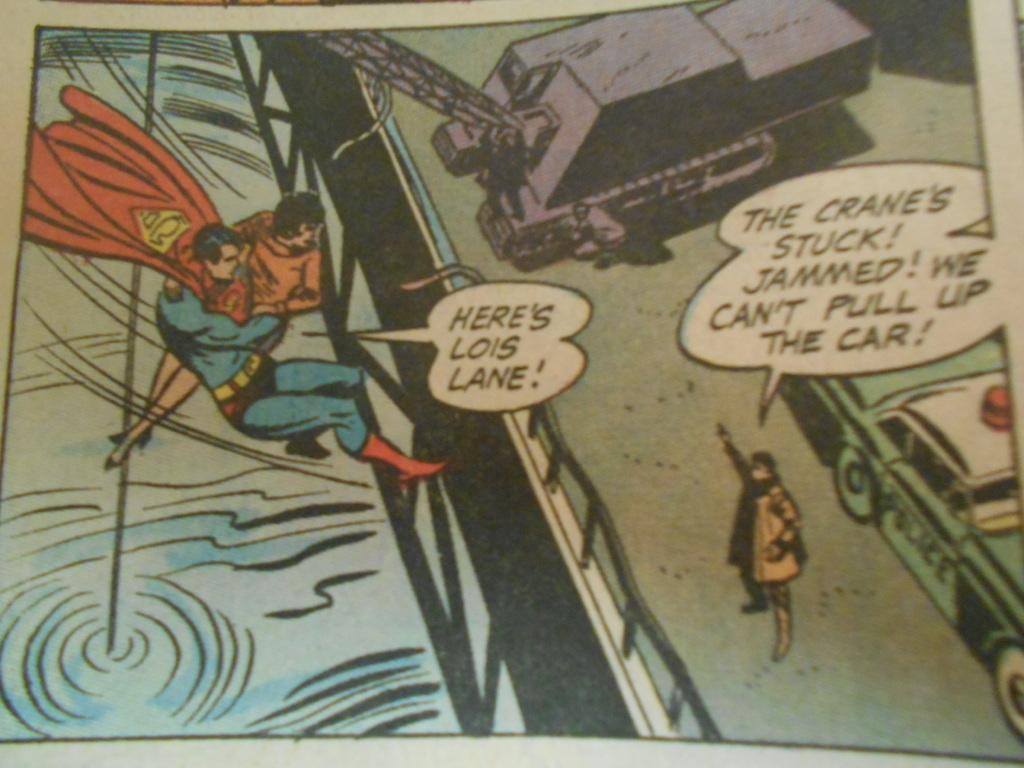Provide a one-sentence caption for the provided image. A comic book panel of Superman saving Lois Lane. 